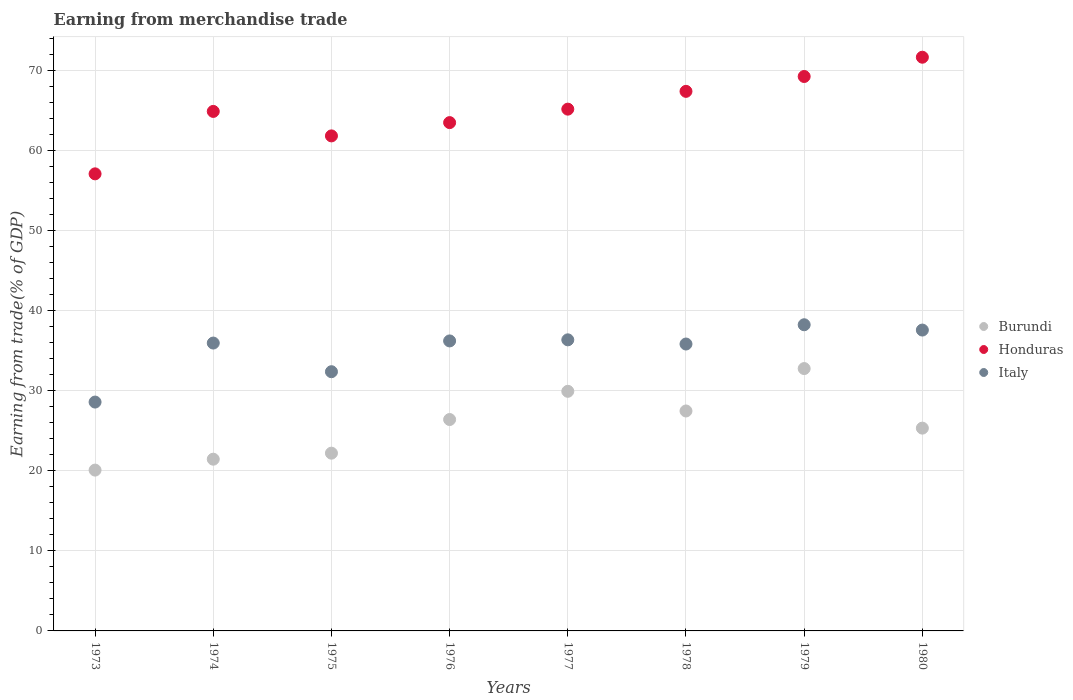Is the number of dotlines equal to the number of legend labels?
Your response must be concise. Yes. What is the earnings from trade in Honduras in 1976?
Provide a succinct answer. 63.5. Across all years, what is the maximum earnings from trade in Burundi?
Your response must be concise. 32.77. Across all years, what is the minimum earnings from trade in Honduras?
Make the answer very short. 57.1. In which year was the earnings from trade in Burundi maximum?
Give a very brief answer. 1979. In which year was the earnings from trade in Burundi minimum?
Offer a terse response. 1973. What is the total earnings from trade in Italy in the graph?
Provide a succinct answer. 281.19. What is the difference between the earnings from trade in Burundi in 1975 and that in 1978?
Provide a succinct answer. -5.27. What is the difference between the earnings from trade in Burundi in 1979 and the earnings from trade in Italy in 1978?
Provide a succinct answer. -3.07. What is the average earnings from trade in Italy per year?
Ensure brevity in your answer.  35.15. In the year 1979, what is the difference between the earnings from trade in Italy and earnings from trade in Burundi?
Provide a short and direct response. 5.47. In how many years, is the earnings from trade in Honduras greater than 68 %?
Ensure brevity in your answer.  2. What is the ratio of the earnings from trade in Burundi in 1973 to that in 1976?
Ensure brevity in your answer.  0.76. Is the difference between the earnings from trade in Italy in 1973 and 1980 greater than the difference between the earnings from trade in Burundi in 1973 and 1980?
Offer a terse response. No. What is the difference between the highest and the second highest earnings from trade in Italy?
Your response must be concise. 0.66. What is the difference between the highest and the lowest earnings from trade in Italy?
Provide a short and direct response. 9.66. Is the earnings from trade in Italy strictly less than the earnings from trade in Burundi over the years?
Ensure brevity in your answer.  No. How many dotlines are there?
Keep it short and to the point. 3. What is the difference between two consecutive major ticks on the Y-axis?
Provide a succinct answer. 10. Are the values on the major ticks of Y-axis written in scientific E-notation?
Your answer should be very brief. No. Does the graph contain grids?
Give a very brief answer. Yes. How are the legend labels stacked?
Offer a terse response. Vertical. What is the title of the graph?
Your answer should be compact. Earning from merchandise trade. Does "Tuvalu" appear as one of the legend labels in the graph?
Your answer should be compact. No. What is the label or title of the X-axis?
Keep it short and to the point. Years. What is the label or title of the Y-axis?
Make the answer very short. Earning from trade(% of GDP). What is the Earning from trade(% of GDP) of Burundi in 1973?
Ensure brevity in your answer.  20.09. What is the Earning from trade(% of GDP) in Honduras in 1973?
Ensure brevity in your answer.  57.1. What is the Earning from trade(% of GDP) of Italy in 1973?
Provide a short and direct response. 28.59. What is the Earning from trade(% of GDP) of Burundi in 1974?
Provide a succinct answer. 21.45. What is the Earning from trade(% of GDP) in Honduras in 1974?
Give a very brief answer. 64.9. What is the Earning from trade(% of GDP) of Italy in 1974?
Your answer should be compact. 35.96. What is the Earning from trade(% of GDP) of Burundi in 1975?
Make the answer very short. 22.21. What is the Earning from trade(% of GDP) of Honduras in 1975?
Provide a short and direct response. 61.84. What is the Earning from trade(% of GDP) of Italy in 1975?
Give a very brief answer. 32.38. What is the Earning from trade(% of GDP) in Burundi in 1976?
Offer a very short reply. 26.41. What is the Earning from trade(% of GDP) in Honduras in 1976?
Provide a succinct answer. 63.5. What is the Earning from trade(% of GDP) in Italy in 1976?
Make the answer very short. 36.23. What is the Earning from trade(% of GDP) in Burundi in 1977?
Provide a short and direct response. 29.93. What is the Earning from trade(% of GDP) of Honduras in 1977?
Offer a terse response. 65.18. What is the Earning from trade(% of GDP) in Italy in 1977?
Your answer should be compact. 36.36. What is the Earning from trade(% of GDP) in Burundi in 1978?
Your answer should be very brief. 27.48. What is the Earning from trade(% of GDP) in Honduras in 1978?
Your answer should be very brief. 67.4. What is the Earning from trade(% of GDP) of Italy in 1978?
Provide a succinct answer. 35.84. What is the Earning from trade(% of GDP) in Burundi in 1979?
Provide a short and direct response. 32.77. What is the Earning from trade(% of GDP) in Honduras in 1979?
Keep it short and to the point. 69.26. What is the Earning from trade(% of GDP) of Italy in 1979?
Provide a succinct answer. 38.25. What is the Earning from trade(% of GDP) in Burundi in 1980?
Provide a succinct answer. 25.33. What is the Earning from trade(% of GDP) in Honduras in 1980?
Make the answer very short. 71.67. What is the Earning from trade(% of GDP) of Italy in 1980?
Your response must be concise. 37.58. Across all years, what is the maximum Earning from trade(% of GDP) of Burundi?
Your answer should be compact. 32.77. Across all years, what is the maximum Earning from trade(% of GDP) of Honduras?
Your response must be concise. 71.67. Across all years, what is the maximum Earning from trade(% of GDP) of Italy?
Your answer should be very brief. 38.25. Across all years, what is the minimum Earning from trade(% of GDP) in Burundi?
Provide a short and direct response. 20.09. Across all years, what is the minimum Earning from trade(% of GDP) of Honduras?
Keep it short and to the point. 57.1. Across all years, what is the minimum Earning from trade(% of GDP) in Italy?
Offer a very short reply. 28.59. What is the total Earning from trade(% of GDP) of Burundi in the graph?
Make the answer very short. 205.67. What is the total Earning from trade(% of GDP) of Honduras in the graph?
Make the answer very short. 520.85. What is the total Earning from trade(% of GDP) in Italy in the graph?
Offer a very short reply. 281.19. What is the difference between the Earning from trade(% of GDP) in Burundi in 1973 and that in 1974?
Offer a terse response. -1.36. What is the difference between the Earning from trade(% of GDP) in Honduras in 1973 and that in 1974?
Offer a very short reply. -7.8. What is the difference between the Earning from trade(% of GDP) of Italy in 1973 and that in 1974?
Offer a terse response. -7.37. What is the difference between the Earning from trade(% of GDP) in Burundi in 1973 and that in 1975?
Offer a very short reply. -2.12. What is the difference between the Earning from trade(% of GDP) in Honduras in 1973 and that in 1975?
Provide a short and direct response. -4.74. What is the difference between the Earning from trade(% of GDP) of Italy in 1973 and that in 1975?
Ensure brevity in your answer.  -3.79. What is the difference between the Earning from trade(% of GDP) of Burundi in 1973 and that in 1976?
Your response must be concise. -6.32. What is the difference between the Earning from trade(% of GDP) in Honduras in 1973 and that in 1976?
Offer a very short reply. -6.4. What is the difference between the Earning from trade(% of GDP) in Italy in 1973 and that in 1976?
Your response must be concise. -7.64. What is the difference between the Earning from trade(% of GDP) of Burundi in 1973 and that in 1977?
Ensure brevity in your answer.  -9.84. What is the difference between the Earning from trade(% of GDP) in Honduras in 1973 and that in 1977?
Provide a succinct answer. -8.08. What is the difference between the Earning from trade(% of GDP) of Italy in 1973 and that in 1977?
Ensure brevity in your answer.  -7.77. What is the difference between the Earning from trade(% of GDP) in Burundi in 1973 and that in 1978?
Offer a terse response. -7.39. What is the difference between the Earning from trade(% of GDP) of Honduras in 1973 and that in 1978?
Make the answer very short. -10.31. What is the difference between the Earning from trade(% of GDP) in Italy in 1973 and that in 1978?
Offer a very short reply. -7.25. What is the difference between the Earning from trade(% of GDP) of Burundi in 1973 and that in 1979?
Provide a short and direct response. -12.68. What is the difference between the Earning from trade(% of GDP) in Honduras in 1973 and that in 1979?
Your response must be concise. -12.16. What is the difference between the Earning from trade(% of GDP) of Italy in 1973 and that in 1979?
Make the answer very short. -9.66. What is the difference between the Earning from trade(% of GDP) in Burundi in 1973 and that in 1980?
Keep it short and to the point. -5.24. What is the difference between the Earning from trade(% of GDP) in Honduras in 1973 and that in 1980?
Keep it short and to the point. -14.57. What is the difference between the Earning from trade(% of GDP) in Italy in 1973 and that in 1980?
Ensure brevity in your answer.  -8.99. What is the difference between the Earning from trade(% of GDP) in Burundi in 1974 and that in 1975?
Offer a terse response. -0.75. What is the difference between the Earning from trade(% of GDP) of Honduras in 1974 and that in 1975?
Provide a short and direct response. 3.06. What is the difference between the Earning from trade(% of GDP) of Italy in 1974 and that in 1975?
Provide a short and direct response. 3.58. What is the difference between the Earning from trade(% of GDP) in Burundi in 1974 and that in 1976?
Give a very brief answer. -4.96. What is the difference between the Earning from trade(% of GDP) in Honduras in 1974 and that in 1976?
Keep it short and to the point. 1.4. What is the difference between the Earning from trade(% of GDP) of Italy in 1974 and that in 1976?
Offer a terse response. -0.27. What is the difference between the Earning from trade(% of GDP) of Burundi in 1974 and that in 1977?
Your answer should be compact. -8.48. What is the difference between the Earning from trade(% of GDP) in Honduras in 1974 and that in 1977?
Your response must be concise. -0.28. What is the difference between the Earning from trade(% of GDP) of Italy in 1974 and that in 1977?
Ensure brevity in your answer.  -0.4. What is the difference between the Earning from trade(% of GDP) in Burundi in 1974 and that in 1978?
Your answer should be compact. -6.02. What is the difference between the Earning from trade(% of GDP) in Honduras in 1974 and that in 1978?
Your answer should be compact. -2.51. What is the difference between the Earning from trade(% of GDP) in Italy in 1974 and that in 1978?
Your response must be concise. 0.12. What is the difference between the Earning from trade(% of GDP) of Burundi in 1974 and that in 1979?
Provide a succinct answer. -11.32. What is the difference between the Earning from trade(% of GDP) in Honduras in 1974 and that in 1979?
Make the answer very short. -4.36. What is the difference between the Earning from trade(% of GDP) in Italy in 1974 and that in 1979?
Give a very brief answer. -2.29. What is the difference between the Earning from trade(% of GDP) of Burundi in 1974 and that in 1980?
Offer a terse response. -3.88. What is the difference between the Earning from trade(% of GDP) in Honduras in 1974 and that in 1980?
Keep it short and to the point. -6.77. What is the difference between the Earning from trade(% of GDP) of Italy in 1974 and that in 1980?
Your answer should be very brief. -1.62. What is the difference between the Earning from trade(% of GDP) in Burundi in 1975 and that in 1976?
Keep it short and to the point. -4.2. What is the difference between the Earning from trade(% of GDP) of Honduras in 1975 and that in 1976?
Keep it short and to the point. -1.66. What is the difference between the Earning from trade(% of GDP) of Italy in 1975 and that in 1976?
Your response must be concise. -3.85. What is the difference between the Earning from trade(% of GDP) in Burundi in 1975 and that in 1977?
Provide a succinct answer. -7.73. What is the difference between the Earning from trade(% of GDP) of Honduras in 1975 and that in 1977?
Your response must be concise. -3.34. What is the difference between the Earning from trade(% of GDP) of Italy in 1975 and that in 1977?
Offer a very short reply. -3.98. What is the difference between the Earning from trade(% of GDP) of Burundi in 1975 and that in 1978?
Keep it short and to the point. -5.27. What is the difference between the Earning from trade(% of GDP) of Honduras in 1975 and that in 1978?
Offer a very short reply. -5.56. What is the difference between the Earning from trade(% of GDP) of Italy in 1975 and that in 1978?
Make the answer very short. -3.46. What is the difference between the Earning from trade(% of GDP) of Burundi in 1975 and that in 1979?
Provide a short and direct response. -10.57. What is the difference between the Earning from trade(% of GDP) of Honduras in 1975 and that in 1979?
Offer a terse response. -7.42. What is the difference between the Earning from trade(% of GDP) in Italy in 1975 and that in 1979?
Offer a very short reply. -5.87. What is the difference between the Earning from trade(% of GDP) of Burundi in 1975 and that in 1980?
Make the answer very short. -3.13. What is the difference between the Earning from trade(% of GDP) of Honduras in 1975 and that in 1980?
Offer a terse response. -9.83. What is the difference between the Earning from trade(% of GDP) in Italy in 1975 and that in 1980?
Give a very brief answer. -5.2. What is the difference between the Earning from trade(% of GDP) of Burundi in 1976 and that in 1977?
Offer a terse response. -3.52. What is the difference between the Earning from trade(% of GDP) in Honduras in 1976 and that in 1977?
Offer a terse response. -1.68. What is the difference between the Earning from trade(% of GDP) of Italy in 1976 and that in 1977?
Your answer should be compact. -0.14. What is the difference between the Earning from trade(% of GDP) in Burundi in 1976 and that in 1978?
Your response must be concise. -1.07. What is the difference between the Earning from trade(% of GDP) in Honduras in 1976 and that in 1978?
Your answer should be very brief. -3.9. What is the difference between the Earning from trade(% of GDP) in Italy in 1976 and that in 1978?
Offer a very short reply. 0.39. What is the difference between the Earning from trade(% of GDP) in Burundi in 1976 and that in 1979?
Your answer should be very brief. -6.37. What is the difference between the Earning from trade(% of GDP) in Honduras in 1976 and that in 1979?
Offer a very short reply. -5.76. What is the difference between the Earning from trade(% of GDP) of Italy in 1976 and that in 1979?
Provide a short and direct response. -2.02. What is the difference between the Earning from trade(% of GDP) in Burundi in 1976 and that in 1980?
Offer a very short reply. 1.07. What is the difference between the Earning from trade(% of GDP) of Honduras in 1976 and that in 1980?
Keep it short and to the point. -8.17. What is the difference between the Earning from trade(% of GDP) of Italy in 1976 and that in 1980?
Provide a succinct answer. -1.36. What is the difference between the Earning from trade(% of GDP) in Burundi in 1977 and that in 1978?
Make the answer very short. 2.46. What is the difference between the Earning from trade(% of GDP) in Honduras in 1977 and that in 1978?
Your answer should be compact. -2.22. What is the difference between the Earning from trade(% of GDP) of Italy in 1977 and that in 1978?
Offer a very short reply. 0.52. What is the difference between the Earning from trade(% of GDP) of Burundi in 1977 and that in 1979?
Give a very brief answer. -2.84. What is the difference between the Earning from trade(% of GDP) of Honduras in 1977 and that in 1979?
Your response must be concise. -4.08. What is the difference between the Earning from trade(% of GDP) of Italy in 1977 and that in 1979?
Provide a short and direct response. -1.88. What is the difference between the Earning from trade(% of GDP) in Burundi in 1977 and that in 1980?
Give a very brief answer. 4.6. What is the difference between the Earning from trade(% of GDP) of Honduras in 1977 and that in 1980?
Offer a terse response. -6.49. What is the difference between the Earning from trade(% of GDP) of Italy in 1977 and that in 1980?
Provide a short and direct response. -1.22. What is the difference between the Earning from trade(% of GDP) of Burundi in 1978 and that in 1979?
Provide a short and direct response. -5.3. What is the difference between the Earning from trade(% of GDP) of Honduras in 1978 and that in 1979?
Give a very brief answer. -1.86. What is the difference between the Earning from trade(% of GDP) in Italy in 1978 and that in 1979?
Your answer should be compact. -2.41. What is the difference between the Earning from trade(% of GDP) in Burundi in 1978 and that in 1980?
Give a very brief answer. 2.14. What is the difference between the Earning from trade(% of GDP) of Honduras in 1978 and that in 1980?
Your answer should be compact. -4.26. What is the difference between the Earning from trade(% of GDP) of Italy in 1978 and that in 1980?
Offer a very short reply. -1.74. What is the difference between the Earning from trade(% of GDP) of Burundi in 1979 and that in 1980?
Your response must be concise. 7.44. What is the difference between the Earning from trade(% of GDP) in Honduras in 1979 and that in 1980?
Keep it short and to the point. -2.41. What is the difference between the Earning from trade(% of GDP) of Italy in 1979 and that in 1980?
Give a very brief answer. 0.66. What is the difference between the Earning from trade(% of GDP) in Burundi in 1973 and the Earning from trade(% of GDP) in Honduras in 1974?
Your answer should be compact. -44.81. What is the difference between the Earning from trade(% of GDP) in Burundi in 1973 and the Earning from trade(% of GDP) in Italy in 1974?
Ensure brevity in your answer.  -15.87. What is the difference between the Earning from trade(% of GDP) in Honduras in 1973 and the Earning from trade(% of GDP) in Italy in 1974?
Provide a succinct answer. 21.14. What is the difference between the Earning from trade(% of GDP) of Burundi in 1973 and the Earning from trade(% of GDP) of Honduras in 1975?
Ensure brevity in your answer.  -41.75. What is the difference between the Earning from trade(% of GDP) of Burundi in 1973 and the Earning from trade(% of GDP) of Italy in 1975?
Give a very brief answer. -12.29. What is the difference between the Earning from trade(% of GDP) in Honduras in 1973 and the Earning from trade(% of GDP) in Italy in 1975?
Offer a very short reply. 24.72. What is the difference between the Earning from trade(% of GDP) in Burundi in 1973 and the Earning from trade(% of GDP) in Honduras in 1976?
Provide a succinct answer. -43.41. What is the difference between the Earning from trade(% of GDP) in Burundi in 1973 and the Earning from trade(% of GDP) in Italy in 1976?
Give a very brief answer. -16.14. What is the difference between the Earning from trade(% of GDP) in Honduras in 1973 and the Earning from trade(% of GDP) in Italy in 1976?
Offer a terse response. 20.87. What is the difference between the Earning from trade(% of GDP) in Burundi in 1973 and the Earning from trade(% of GDP) in Honduras in 1977?
Give a very brief answer. -45.09. What is the difference between the Earning from trade(% of GDP) in Burundi in 1973 and the Earning from trade(% of GDP) in Italy in 1977?
Offer a very short reply. -16.27. What is the difference between the Earning from trade(% of GDP) of Honduras in 1973 and the Earning from trade(% of GDP) of Italy in 1977?
Your response must be concise. 20.73. What is the difference between the Earning from trade(% of GDP) of Burundi in 1973 and the Earning from trade(% of GDP) of Honduras in 1978?
Offer a terse response. -47.31. What is the difference between the Earning from trade(% of GDP) of Burundi in 1973 and the Earning from trade(% of GDP) of Italy in 1978?
Keep it short and to the point. -15.75. What is the difference between the Earning from trade(% of GDP) of Honduras in 1973 and the Earning from trade(% of GDP) of Italy in 1978?
Your answer should be very brief. 21.26. What is the difference between the Earning from trade(% of GDP) in Burundi in 1973 and the Earning from trade(% of GDP) in Honduras in 1979?
Offer a terse response. -49.17. What is the difference between the Earning from trade(% of GDP) of Burundi in 1973 and the Earning from trade(% of GDP) of Italy in 1979?
Your answer should be very brief. -18.16. What is the difference between the Earning from trade(% of GDP) in Honduras in 1973 and the Earning from trade(% of GDP) in Italy in 1979?
Offer a terse response. 18.85. What is the difference between the Earning from trade(% of GDP) of Burundi in 1973 and the Earning from trade(% of GDP) of Honduras in 1980?
Your response must be concise. -51.58. What is the difference between the Earning from trade(% of GDP) of Burundi in 1973 and the Earning from trade(% of GDP) of Italy in 1980?
Offer a terse response. -17.49. What is the difference between the Earning from trade(% of GDP) in Honduras in 1973 and the Earning from trade(% of GDP) in Italy in 1980?
Offer a terse response. 19.51. What is the difference between the Earning from trade(% of GDP) in Burundi in 1974 and the Earning from trade(% of GDP) in Honduras in 1975?
Your answer should be compact. -40.39. What is the difference between the Earning from trade(% of GDP) in Burundi in 1974 and the Earning from trade(% of GDP) in Italy in 1975?
Provide a succinct answer. -10.93. What is the difference between the Earning from trade(% of GDP) in Honduras in 1974 and the Earning from trade(% of GDP) in Italy in 1975?
Provide a short and direct response. 32.52. What is the difference between the Earning from trade(% of GDP) of Burundi in 1974 and the Earning from trade(% of GDP) of Honduras in 1976?
Your answer should be very brief. -42.05. What is the difference between the Earning from trade(% of GDP) of Burundi in 1974 and the Earning from trade(% of GDP) of Italy in 1976?
Ensure brevity in your answer.  -14.77. What is the difference between the Earning from trade(% of GDP) of Honduras in 1974 and the Earning from trade(% of GDP) of Italy in 1976?
Your answer should be compact. 28.67. What is the difference between the Earning from trade(% of GDP) in Burundi in 1974 and the Earning from trade(% of GDP) in Honduras in 1977?
Ensure brevity in your answer.  -43.73. What is the difference between the Earning from trade(% of GDP) in Burundi in 1974 and the Earning from trade(% of GDP) in Italy in 1977?
Offer a very short reply. -14.91. What is the difference between the Earning from trade(% of GDP) in Honduras in 1974 and the Earning from trade(% of GDP) in Italy in 1977?
Keep it short and to the point. 28.53. What is the difference between the Earning from trade(% of GDP) in Burundi in 1974 and the Earning from trade(% of GDP) in Honduras in 1978?
Your answer should be very brief. -45.95. What is the difference between the Earning from trade(% of GDP) in Burundi in 1974 and the Earning from trade(% of GDP) in Italy in 1978?
Provide a succinct answer. -14.39. What is the difference between the Earning from trade(% of GDP) in Honduras in 1974 and the Earning from trade(% of GDP) in Italy in 1978?
Your answer should be very brief. 29.06. What is the difference between the Earning from trade(% of GDP) of Burundi in 1974 and the Earning from trade(% of GDP) of Honduras in 1979?
Give a very brief answer. -47.81. What is the difference between the Earning from trade(% of GDP) in Burundi in 1974 and the Earning from trade(% of GDP) in Italy in 1979?
Your answer should be very brief. -16.79. What is the difference between the Earning from trade(% of GDP) in Honduras in 1974 and the Earning from trade(% of GDP) in Italy in 1979?
Offer a terse response. 26.65. What is the difference between the Earning from trade(% of GDP) of Burundi in 1974 and the Earning from trade(% of GDP) of Honduras in 1980?
Keep it short and to the point. -50.21. What is the difference between the Earning from trade(% of GDP) in Burundi in 1974 and the Earning from trade(% of GDP) in Italy in 1980?
Offer a terse response. -16.13. What is the difference between the Earning from trade(% of GDP) in Honduras in 1974 and the Earning from trade(% of GDP) in Italy in 1980?
Your answer should be compact. 27.31. What is the difference between the Earning from trade(% of GDP) in Burundi in 1975 and the Earning from trade(% of GDP) in Honduras in 1976?
Ensure brevity in your answer.  -41.29. What is the difference between the Earning from trade(% of GDP) in Burundi in 1975 and the Earning from trade(% of GDP) in Italy in 1976?
Offer a terse response. -14.02. What is the difference between the Earning from trade(% of GDP) of Honduras in 1975 and the Earning from trade(% of GDP) of Italy in 1976?
Your response must be concise. 25.61. What is the difference between the Earning from trade(% of GDP) in Burundi in 1975 and the Earning from trade(% of GDP) in Honduras in 1977?
Keep it short and to the point. -42.98. What is the difference between the Earning from trade(% of GDP) in Burundi in 1975 and the Earning from trade(% of GDP) in Italy in 1977?
Offer a terse response. -14.16. What is the difference between the Earning from trade(% of GDP) in Honduras in 1975 and the Earning from trade(% of GDP) in Italy in 1977?
Offer a terse response. 25.48. What is the difference between the Earning from trade(% of GDP) of Burundi in 1975 and the Earning from trade(% of GDP) of Honduras in 1978?
Your answer should be very brief. -45.2. What is the difference between the Earning from trade(% of GDP) in Burundi in 1975 and the Earning from trade(% of GDP) in Italy in 1978?
Offer a very short reply. -13.63. What is the difference between the Earning from trade(% of GDP) of Honduras in 1975 and the Earning from trade(% of GDP) of Italy in 1978?
Provide a short and direct response. 26. What is the difference between the Earning from trade(% of GDP) of Burundi in 1975 and the Earning from trade(% of GDP) of Honduras in 1979?
Give a very brief answer. -47.06. What is the difference between the Earning from trade(% of GDP) of Burundi in 1975 and the Earning from trade(% of GDP) of Italy in 1979?
Your answer should be compact. -16.04. What is the difference between the Earning from trade(% of GDP) of Honduras in 1975 and the Earning from trade(% of GDP) of Italy in 1979?
Give a very brief answer. 23.59. What is the difference between the Earning from trade(% of GDP) of Burundi in 1975 and the Earning from trade(% of GDP) of Honduras in 1980?
Keep it short and to the point. -49.46. What is the difference between the Earning from trade(% of GDP) of Burundi in 1975 and the Earning from trade(% of GDP) of Italy in 1980?
Your answer should be compact. -15.38. What is the difference between the Earning from trade(% of GDP) in Honduras in 1975 and the Earning from trade(% of GDP) in Italy in 1980?
Offer a terse response. 24.26. What is the difference between the Earning from trade(% of GDP) of Burundi in 1976 and the Earning from trade(% of GDP) of Honduras in 1977?
Your answer should be compact. -38.77. What is the difference between the Earning from trade(% of GDP) in Burundi in 1976 and the Earning from trade(% of GDP) in Italy in 1977?
Ensure brevity in your answer.  -9.96. What is the difference between the Earning from trade(% of GDP) of Honduras in 1976 and the Earning from trade(% of GDP) of Italy in 1977?
Ensure brevity in your answer.  27.14. What is the difference between the Earning from trade(% of GDP) in Burundi in 1976 and the Earning from trade(% of GDP) in Honduras in 1978?
Your response must be concise. -41. What is the difference between the Earning from trade(% of GDP) of Burundi in 1976 and the Earning from trade(% of GDP) of Italy in 1978?
Keep it short and to the point. -9.43. What is the difference between the Earning from trade(% of GDP) of Honduras in 1976 and the Earning from trade(% of GDP) of Italy in 1978?
Ensure brevity in your answer.  27.66. What is the difference between the Earning from trade(% of GDP) of Burundi in 1976 and the Earning from trade(% of GDP) of Honduras in 1979?
Give a very brief answer. -42.85. What is the difference between the Earning from trade(% of GDP) of Burundi in 1976 and the Earning from trade(% of GDP) of Italy in 1979?
Provide a succinct answer. -11.84. What is the difference between the Earning from trade(% of GDP) of Honduras in 1976 and the Earning from trade(% of GDP) of Italy in 1979?
Make the answer very short. 25.25. What is the difference between the Earning from trade(% of GDP) in Burundi in 1976 and the Earning from trade(% of GDP) in Honduras in 1980?
Ensure brevity in your answer.  -45.26. What is the difference between the Earning from trade(% of GDP) in Burundi in 1976 and the Earning from trade(% of GDP) in Italy in 1980?
Your answer should be compact. -11.18. What is the difference between the Earning from trade(% of GDP) of Honduras in 1976 and the Earning from trade(% of GDP) of Italy in 1980?
Keep it short and to the point. 25.92. What is the difference between the Earning from trade(% of GDP) of Burundi in 1977 and the Earning from trade(% of GDP) of Honduras in 1978?
Make the answer very short. -37.47. What is the difference between the Earning from trade(% of GDP) in Burundi in 1977 and the Earning from trade(% of GDP) in Italy in 1978?
Offer a very short reply. -5.91. What is the difference between the Earning from trade(% of GDP) in Honduras in 1977 and the Earning from trade(% of GDP) in Italy in 1978?
Provide a short and direct response. 29.34. What is the difference between the Earning from trade(% of GDP) of Burundi in 1977 and the Earning from trade(% of GDP) of Honduras in 1979?
Your response must be concise. -39.33. What is the difference between the Earning from trade(% of GDP) in Burundi in 1977 and the Earning from trade(% of GDP) in Italy in 1979?
Your answer should be very brief. -8.31. What is the difference between the Earning from trade(% of GDP) in Honduras in 1977 and the Earning from trade(% of GDP) in Italy in 1979?
Make the answer very short. 26.93. What is the difference between the Earning from trade(% of GDP) in Burundi in 1977 and the Earning from trade(% of GDP) in Honduras in 1980?
Offer a very short reply. -41.74. What is the difference between the Earning from trade(% of GDP) in Burundi in 1977 and the Earning from trade(% of GDP) in Italy in 1980?
Provide a short and direct response. -7.65. What is the difference between the Earning from trade(% of GDP) in Honduras in 1977 and the Earning from trade(% of GDP) in Italy in 1980?
Your answer should be very brief. 27.6. What is the difference between the Earning from trade(% of GDP) of Burundi in 1978 and the Earning from trade(% of GDP) of Honduras in 1979?
Keep it short and to the point. -41.78. What is the difference between the Earning from trade(% of GDP) in Burundi in 1978 and the Earning from trade(% of GDP) in Italy in 1979?
Your answer should be compact. -10.77. What is the difference between the Earning from trade(% of GDP) of Honduras in 1978 and the Earning from trade(% of GDP) of Italy in 1979?
Make the answer very short. 29.16. What is the difference between the Earning from trade(% of GDP) of Burundi in 1978 and the Earning from trade(% of GDP) of Honduras in 1980?
Your answer should be very brief. -44.19. What is the difference between the Earning from trade(% of GDP) of Burundi in 1978 and the Earning from trade(% of GDP) of Italy in 1980?
Make the answer very short. -10.11. What is the difference between the Earning from trade(% of GDP) in Honduras in 1978 and the Earning from trade(% of GDP) in Italy in 1980?
Offer a very short reply. 29.82. What is the difference between the Earning from trade(% of GDP) of Burundi in 1979 and the Earning from trade(% of GDP) of Honduras in 1980?
Give a very brief answer. -38.89. What is the difference between the Earning from trade(% of GDP) in Burundi in 1979 and the Earning from trade(% of GDP) in Italy in 1980?
Keep it short and to the point. -4.81. What is the difference between the Earning from trade(% of GDP) of Honduras in 1979 and the Earning from trade(% of GDP) of Italy in 1980?
Ensure brevity in your answer.  31.68. What is the average Earning from trade(% of GDP) in Burundi per year?
Your answer should be very brief. 25.71. What is the average Earning from trade(% of GDP) of Honduras per year?
Provide a short and direct response. 65.11. What is the average Earning from trade(% of GDP) of Italy per year?
Keep it short and to the point. 35.15. In the year 1973, what is the difference between the Earning from trade(% of GDP) in Burundi and Earning from trade(% of GDP) in Honduras?
Your response must be concise. -37.01. In the year 1973, what is the difference between the Earning from trade(% of GDP) of Burundi and Earning from trade(% of GDP) of Italy?
Provide a succinct answer. -8.5. In the year 1973, what is the difference between the Earning from trade(% of GDP) of Honduras and Earning from trade(% of GDP) of Italy?
Provide a short and direct response. 28.51. In the year 1974, what is the difference between the Earning from trade(% of GDP) of Burundi and Earning from trade(% of GDP) of Honduras?
Offer a terse response. -43.44. In the year 1974, what is the difference between the Earning from trade(% of GDP) of Burundi and Earning from trade(% of GDP) of Italy?
Provide a succinct answer. -14.51. In the year 1974, what is the difference between the Earning from trade(% of GDP) of Honduras and Earning from trade(% of GDP) of Italy?
Make the answer very short. 28.94. In the year 1975, what is the difference between the Earning from trade(% of GDP) in Burundi and Earning from trade(% of GDP) in Honduras?
Your answer should be compact. -39.63. In the year 1975, what is the difference between the Earning from trade(% of GDP) of Burundi and Earning from trade(% of GDP) of Italy?
Ensure brevity in your answer.  -10.18. In the year 1975, what is the difference between the Earning from trade(% of GDP) in Honduras and Earning from trade(% of GDP) in Italy?
Ensure brevity in your answer.  29.46. In the year 1976, what is the difference between the Earning from trade(% of GDP) in Burundi and Earning from trade(% of GDP) in Honduras?
Make the answer very short. -37.09. In the year 1976, what is the difference between the Earning from trade(% of GDP) in Burundi and Earning from trade(% of GDP) in Italy?
Your answer should be compact. -9.82. In the year 1976, what is the difference between the Earning from trade(% of GDP) of Honduras and Earning from trade(% of GDP) of Italy?
Provide a short and direct response. 27.27. In the year 1977, what is the difference between the Earning from trade(% of GDP) in Burundi and Earning from trade(% of GDP) in Honduras?
Your answer should be very brief. -35.25. In the year 1977, what is the difference between the Earning from trade(% of GDP) of Burundi and Earning from trade(% of GDP) of Italy?
Provide a succinct answer. -6.43. In the year 1977, what is the difference between the Earning from trade(% of GDP) in Honduras and Earning from trade(% of GDP) in Italy?
Make the answer very short. 28.82. In the year 1978, what is the difference between the Earning from trade(% of GDP) in Burundi and Earning from trade(% of GDP) in Honduras?
Provide a succinct answer. -39.93. In the year 1978, what is the difference between the Earning from trade(% of GDP) of Burundi and Earning from trade(% of GDP) of Italy?
Your answer should be very brief. -8.36. In the year 1978, what is the difference between the Earning from trade(% of GDP) in Honduras and Earning from trade(% of GDP) in Italy?
Provide a short and direct response. 31.56. In the year 1979, what is the difference between the Earning from trade(% of GDP) of Burundi and Earning from trade(% of GDP) of Honduras?
Offer a very short reply. -36.49. In the year 1979, what is the difference between the Earning from trade(% of GDP) in Burundi and Earning from trade(% of GDP) in Italy?
Your answer should be compact. -5.47. In the year 1979, what is the difference between the Earning from trade(% of GDP) of Honduras and Earning from trade(% of GDP) of Italy?
Your answer should be compact. 31.01. In the year 1980, what is the difference between the Earning from trade(% of GDP) in Burundi and Earning from trade(% of GDP) in Honduras?
Ensure brevity in your answer.  -46.33. In the year 1980, what is the difference between the Earning from trade(% of GDP) of Burundi and Earning from trade(% of GDP) of Italy?
Keep it short and to the point. -12.25. In the year 1980, what is the difference between the Earning from trade(% of GDP) of Honduras and Earning from trade(% of GDP) of Italy?
Make the answer very short. 34.08. What is the ratio of the Earning from trade(% of GDP) in Burundi in 1973 to that in 1974?
Provide a succinct answer. 0.94. What is the ratio of the Earning from trade(% of GDP) in Honduras in 1973 to that in 1974?
Keep it short and to the point. 0.88. What is the ratio of the Earning from trade(% of GDP) of Italy in 1973 to that in 1974?
Offer a terse response. 0.8. What is the ratio of the Earning from trade(% of GDP) in Burundi in 1973 to that in 1975?
Your answer should be very brief. 0.9. What is the ratio of the Earning from trade(% of GDP) of Honduras in 1973 to that in 1975?
Ensure brevity in your answer.  0.92. What is the ratio of the Earning from trade(% of GDP) in Italy in 1973 to that in 1975?
Your answer should be compact. 0.88. What is the ratio of the Earning from trade(% of GDP) in Burundi in 1973 to that in 1976?
Give a very brief answer. 0.76. What is the ratio of the Earning from trade(% of GDP) of Honduras in 1973 to that in 1976?
Make the answer very short. 0.9. What is the ratio of the Earning from trade(% of GDP) of Italy in 1973 to that in 1976?
Provide a succinct answer. 0.79. What is the ratio of the Earning from trade(% of GDP) of Burundi in 1973 to that in 1977?
Provide a short and direct response. 0.67. What is the ratio of the Earning from trade(% of GDP) in Honduras in 1973 to that in 1977?
Make the answer very short. 0.88. What is the ratio of the Earning from trade(% of GDP) in Italy in 1973 to that in 1977?
Make the answer very short. 0.79. What is the ratio of the Earning from trade(% of GDP) in Burundi in 1973 to that in 1978?
Your answer should be compact. 0.73. What is the ratio of the Earning from trade(% of GDP) of Honduras in 1973 to that in 1978?
Offer a very short reply. 0.85. What is the ratio of the Earning from trade(% of GDP) of Italy in 1973 to that in 1978?
Your answer should be very brief. 0.8. What is the ratio of the Earning from trade(% of GDP) in Burundi in 1973 to that in 1979?
Your response must be concise. 0.61. What is the ratio of the Earning from trade(% of GDP) of Honduras in 1973 to that in 1979?
Give a very brief answer. 0.82. What is the ratio of the Earning from trade(% of GDP) of Italy in 1973 to that in 1979?
Give a very brief answer. 0.75. What is the ratio of the Earning from trade(% of GDP) of Burundi in 1973 to that in 1980?
Your answer should be very brief. 0.79. What is the ratio of the Earning from trade(% of GDP) in Honduras in 1973 to that in 1980?
Your answer should be very brief. 0.8. What is the ratio of the Earning from trade(% of GDP) of Italy in 1973 to that in 1980?
Offer a very short reply. 0.76. What is the ratio of the Earning from trade(% of GDP) in Burundi in 1974 to that in 1975?
Keep it short and to the point. 0.97. What is the ratio of the Earning from trade(% of GDP) in Honduras in 1974 to that in 1975?
Your response must be concise. 1.05. What is the ratio of the Earning from trade(% of GDP) in Italy in 1974 to that in 1975?
Offer a very short reply. 1.11. What is the ratio of the Earning from trade(% of GDP) in Burundi in 1974 to that in 1976?
Keep it short and to the point. 0.81. What is the ratio of the Earning from trade(% of GDP) in Italy in 1974 to that in 1976?
Offer a terse response. 0.99. What is the ratio of the Earning from trade(% of GDP) of Burundi in 1974 to that in 1977?
Offer a very short reply. 0.72. What is the ratio of the Earning from trade(% of GDP) of Italy in 1974 to that in 1977?
Offer a terse response. 0.99. What is the ratio of the Earning from trade(% of GDP) in Burundi in 1974 to that in 1978?
Offer a very short reply. 0.78. What is the ratio of the Earning from trade(% of GDP) in Honduras in 1974 to that in 1978?
Keep it short and to the point. 0.96. What is the ratio of the Earning from trade(% of GDP) in Italy in 1974 to that in 1978?
Ensure brevity in your answer.  1. What is the ratio of the Earning from trade(% of GDP) of Burundi in 1974 to that in 1979?
Keep it short and to the point. 0.65. What is the ratio of the Earning from trade(% of GDP) of Honduras in 1974 to that in 1979?
Provide a succinct answer. 0.94. What is the ratio of the Earning from trade(% of GDP) of Italy in 1974 to that in 1979?
Your answer should be compact. 0.94. What is the ratio of the Earning from trade(% of GDP) of Burundi in 1974 to that in 1980?
Offer a very short reply. 0.85. What is the ratio of the Earning from trade(% of GDP) in Honduras in 1974 to that in 1980?
Offer a terse response. 0.91. What is the ratio of the Earning from trade(% of GDP) of Italy in 1974 to that in 1980?
Offer a very short reply. 0.96. What is the ratio of the Earning from trade(% of GDP) of Burundi in 1975 to that in 1976?
Your answer should be compact. 0.84. What is the ratio of the Earning from trade(% of GDP) in Honduras in 1975 to that in 1976?
Provide a short and direct response. 0.97. What is the ratio of the Earning from trade(% of GDP) of Italy in 1975 to that in 1976?
Provide a succinct answer. 0.89. What is the ratio of the Earning from trade(% of GDP) of Burundi in 1975 to that in 1977?
Your answer should be compact. 0.74. What is the ratio of the Earning from trade(% of GDP) in Honduras in 1975 to that in 1977?
Your answer should be compact. 0.95. What is the ratio of the Earning from trade(% of GDP) of Italy in 1975 to that in 1977?
Keep it short and to the point. 0.89. What is the ratio of the Earning from trade(% of GDP) of Burundi in 1975 to that in 1978?
Ensure brevity in your answer.  0.81. What is the ratio of the Earning from trade(% of GDP) in Honduras in 1975 to that in 1978?
Your answer should be very brief. 0.92. What is the ratio of the Earning from trade(% of GDP) of Italy in 1975 to that in 1978?
Make the answer very short. 0.9. What is the ratio of the Earning from trade(% of GDP) in Burundi in 1975 to that in 1979?
Make the answer very short. 0.68. What is the ratio of the Earning from trade(% of GDP) of Honduras in 1975 to that in 1979?
Ensure brevity in your answer.  0.89. What is the ratio of the Earning from trade(% of GDP) of Italy in 1975 to that in 1979?
Ensure brevity in your answer.  0.85. What is the ratio of the Earning from trade(% of GDP) of Burundi in 1975 to that in 1980?
Make the answer very short. 0.88. What is the ratio of the Earning from trade(% of GDP) of Honduras in 1975 to that in 1980?
Keep it short and to the point. 0.86. What is the ratio of the Earning from trade(% of GDP) in Italy in 1975 to that in 1980?
Your response must be concise. 0.86. What is the ratio of the Earning from trade(% of GDP) of Burundi in 1976 to that in 1977?
Your answer should be very brief. 0.88. What is the ratio of the Earning from trade(% of GDP) of Honduras in 1976 to that in 1977?
Your response must be concise. 0.97. What is the ratio of the Earning from trade(% of GDP) of Italy in 1976 to that in 1977?
Provide a succinct answer. 1. What is the ratio of the Earning from trade(% of GDP) in Burundi in 1976 to that in 1978?
Your answer should be compact. 0.96. What is the ratio of the Earning from trade(% of GDP) of Honduras in 1976 to that in 1978?
Keep it short and to the point. 0.94. What is the ratio of the Earning from trade(% of GDP) in Italy in 1976 to that in 1978?
Ensure brevity in your answer.  1.01. What is the ratio of the Earning from trade(% of GDP) of Burundi in 1976 to that in 1979?
Ensure brevity in your answer.  0.81. What is the ratio of the Earning from trade(% of GDP) in Honduras in 1976 to that in 1979?
Keep it short and to the point. 0.92. What is the ratio of the Earning from trade(% of GDP) of Italy in 1976 to that in 1979?
Your answer should be very brief. 0.95. What is the ratio of the Earning from trade(% of GDP) of Burundi in 1976 to that in 1980?
Ensure brevity in your answer.  1.04. What is the ratio of the Earning from trade(% of GDP) in Honduras in 1976 to that in 1980?
Your response must be concise. 0.89. What is the ratio of the Earning from trade(% of GDP) in Italy in 1976 to that in 1980?
Your answer should be very brief. 0.96. What is the ratio of the Earning from trade(% of GDP) of Burundi in 1977 to that in 1978?
Your answer should be compact. 1.09. What is the ratio of the Earning from trade(% of GDP) of Honduras in 1977 to that in 1978?
Your answer should be compact. 0.97. What is the ratio of the Earning from trade(% of GDP) in Italy in 1977 to that in 1978?
Your answer should be very brief. 1.01. What is the ratio of the Earning from trade(% of GDP) of Burundi in 1977 to that in 1979?
Offer a very short reply. 0.91. What is the ratio of the Earning from trade(% of GDP) of Honduras in 1977 to that in 1979?
Your response must be concise. 0.94. What is the ratio of the Earning from trade(% of GDP) in Italy in 1977 to that in 1979?
Provide a short and direct response. 0.95. What is the ratio of the Earning from trade(% of GDP) of Burundi in 1977 to that in 1980?
Provide a short and direct response. 1.18. What is the ratio of the Earning from trade(% of GDP) in Honduras in 1977 to that in 1980?
Offer a very short reply. 0.91. What is the ratio of the Earning from trade(% of GDP) of Italy in 1977 to that in 1980?
Ensure brevity in your answer.  0.97. What is the ratio of the Earning from trade(% of GDP) of Burundi in 1978 to that in 1979?
Make the answer very short. 0.84. What is the ratio of the Earning from trade(% of GDP) in Honduras in 1978 to that in 1979?
Offer a very short reply. 0.97. What is the ratio of the Earning from trade(% of GDP) in Italy in 1978 to that in 1979?
Provide a succinct answer. 0.94. What is the ratio of the Earning from trade(% of GDP) in Burundi in 1978 to that in 1980?
Keep it short and to the point. 1.08. What is the ratio of the Earning from trade(% of GDP) in Honduras in 1978 to that in 1980?
Offer a terse response. 0.94. What is the ratio of the Earning from trade(% of GDP) of Italy in 1978 to that in 1980?
Make the answer very short. 0.95. What is the ratio of the Earning from trade(% of GDP) in Burundi in 1979 to that in 1980?
Provide a short and direct response. 1.29. What is the ratio of the Earning from trade(% of GDP) of Honduras in 1979 to that in 1980?
Your response must be concise. 0.97. What is the ratio of the Earning from trade(% of GDP) of Italy in 1979 to that in 1980?
Provide a short and direct response. 1.02. What is the difference between the highest and the second highest Earning from trade(% of GDP) of Burundi?
Provide a succinct answer. 2.84. What is the difference between the highest and the second highest Earning from trade(% of GDP) in Honduras?
Your answer should be very brief. 2.41. What is the difference between the highest and the second highest Earning from trade(% of GDP) of Italy?
Make the answer very short. 0.66. What is the difference between the highest and the lowest Earning from trade(% of GDP) of Burundi?
Give a very brief answer. 12.68. What is the difference between the highest and the lowest Earning from trade(% of GDP) in Honduras?
Provide a short and direct response. 14.57. What is the difference between the highest and the lowest Earning from trade(% of GDP) of Italy?
Your response must be concise. 9.66. 